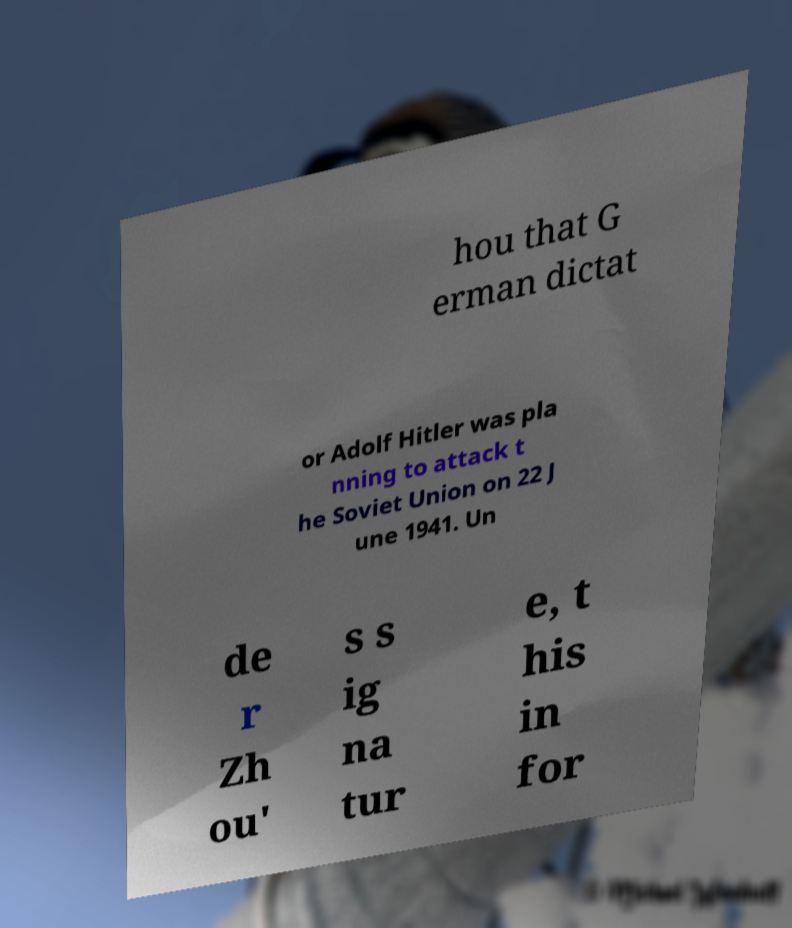Please identify and transcribe the text found in this image. hou that G erman dictat or Adolf Hitler was pla nning to attack t he Soviet Union on 22 J une 1941. Un de r Zh ou' s s ig na tur e, t his in for 